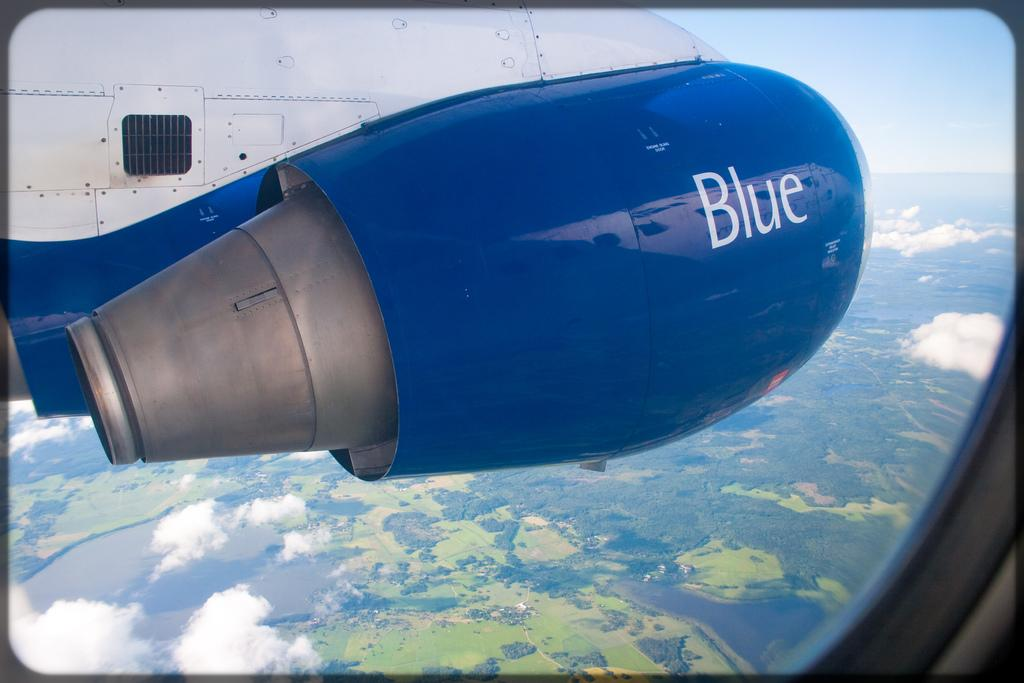<image>
Relay a brief, clear account of the picture shown. Wing mounted engine of a Blue jet is shown in flight against the greenery on the ground. 